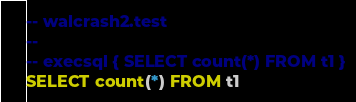<code> <loc_0><loc_0><loc_500><loc_500><_SQL_>-- walcrash2.test
-- 
-- execsql { SELECT count(*) FROM t1 }
SELECT count(*) FROM t1</code> 